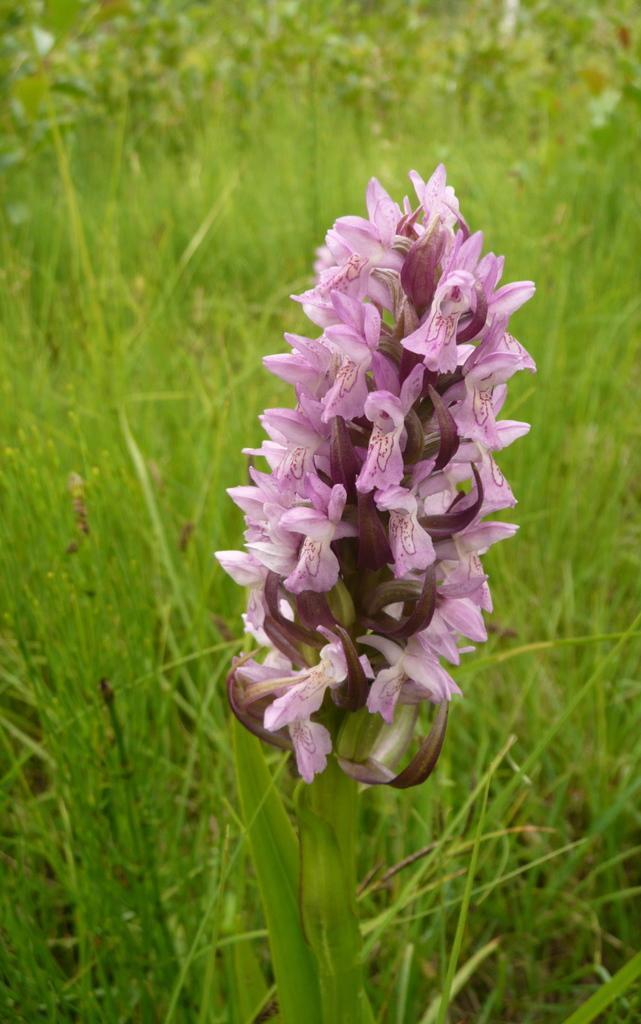In one or two sentences, can you explain what this image depicts? In the image we can see there are flowers on the plant and there are plants on the ground. 